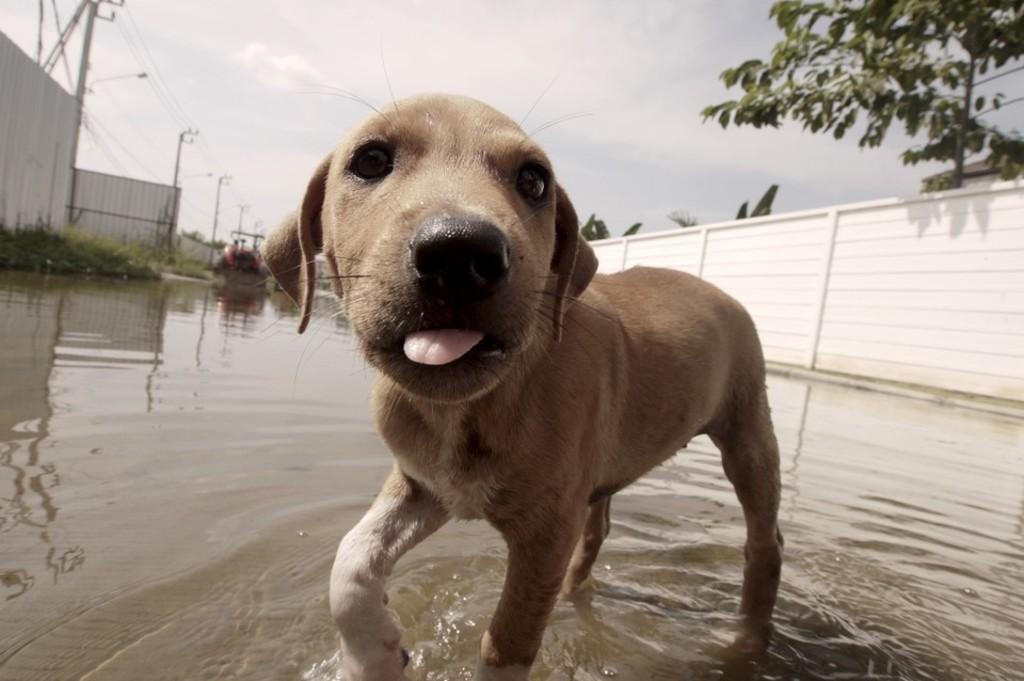In one or two sentences, can you explain what this image depicts? As we can see in the image there is a dog, water, street lamp, current poles and a tree. On the top there is sky. 